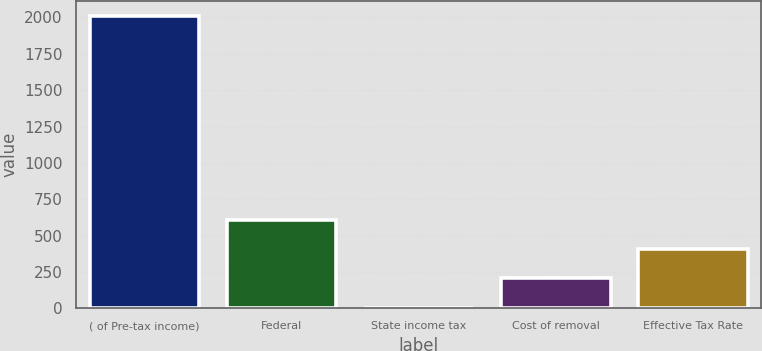<chart> <loc_0><loc_0><loc_500><loc_500><bar_chart><fcel>( of Pre-tax income)<fcel>Federal<fcel>State income tax<fcel>Cost of removal<fcel>Effective Tax Rate<nl><fcel>2013<fcel>606.7<fcel>4<fcel>204.9<fcel>405.8<nl></chart> 